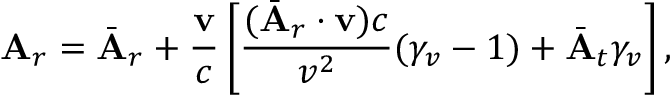Convert formula to latex. <formula><loc_0><loc_0><loc_500><loc_500>A _ { r } = \bar { A } _ { r } + \frac { v } { c } \left [ \frac { ( \bar { A } _ { r } \cdot v ) c } { v ^ { 2 } } ( \gamma _ { v } - 1 ) + \bar { A } _ { t } \gamma _ { v } \right ] ,</formula> 